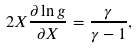Convert formula to latex. <formula><loc_0><loc_0><loc_500><loc_500>2 X \frac { \partial \ln g } { \partial X } = \frac { \gamma } { \gamma - 1 } ,</formula> 